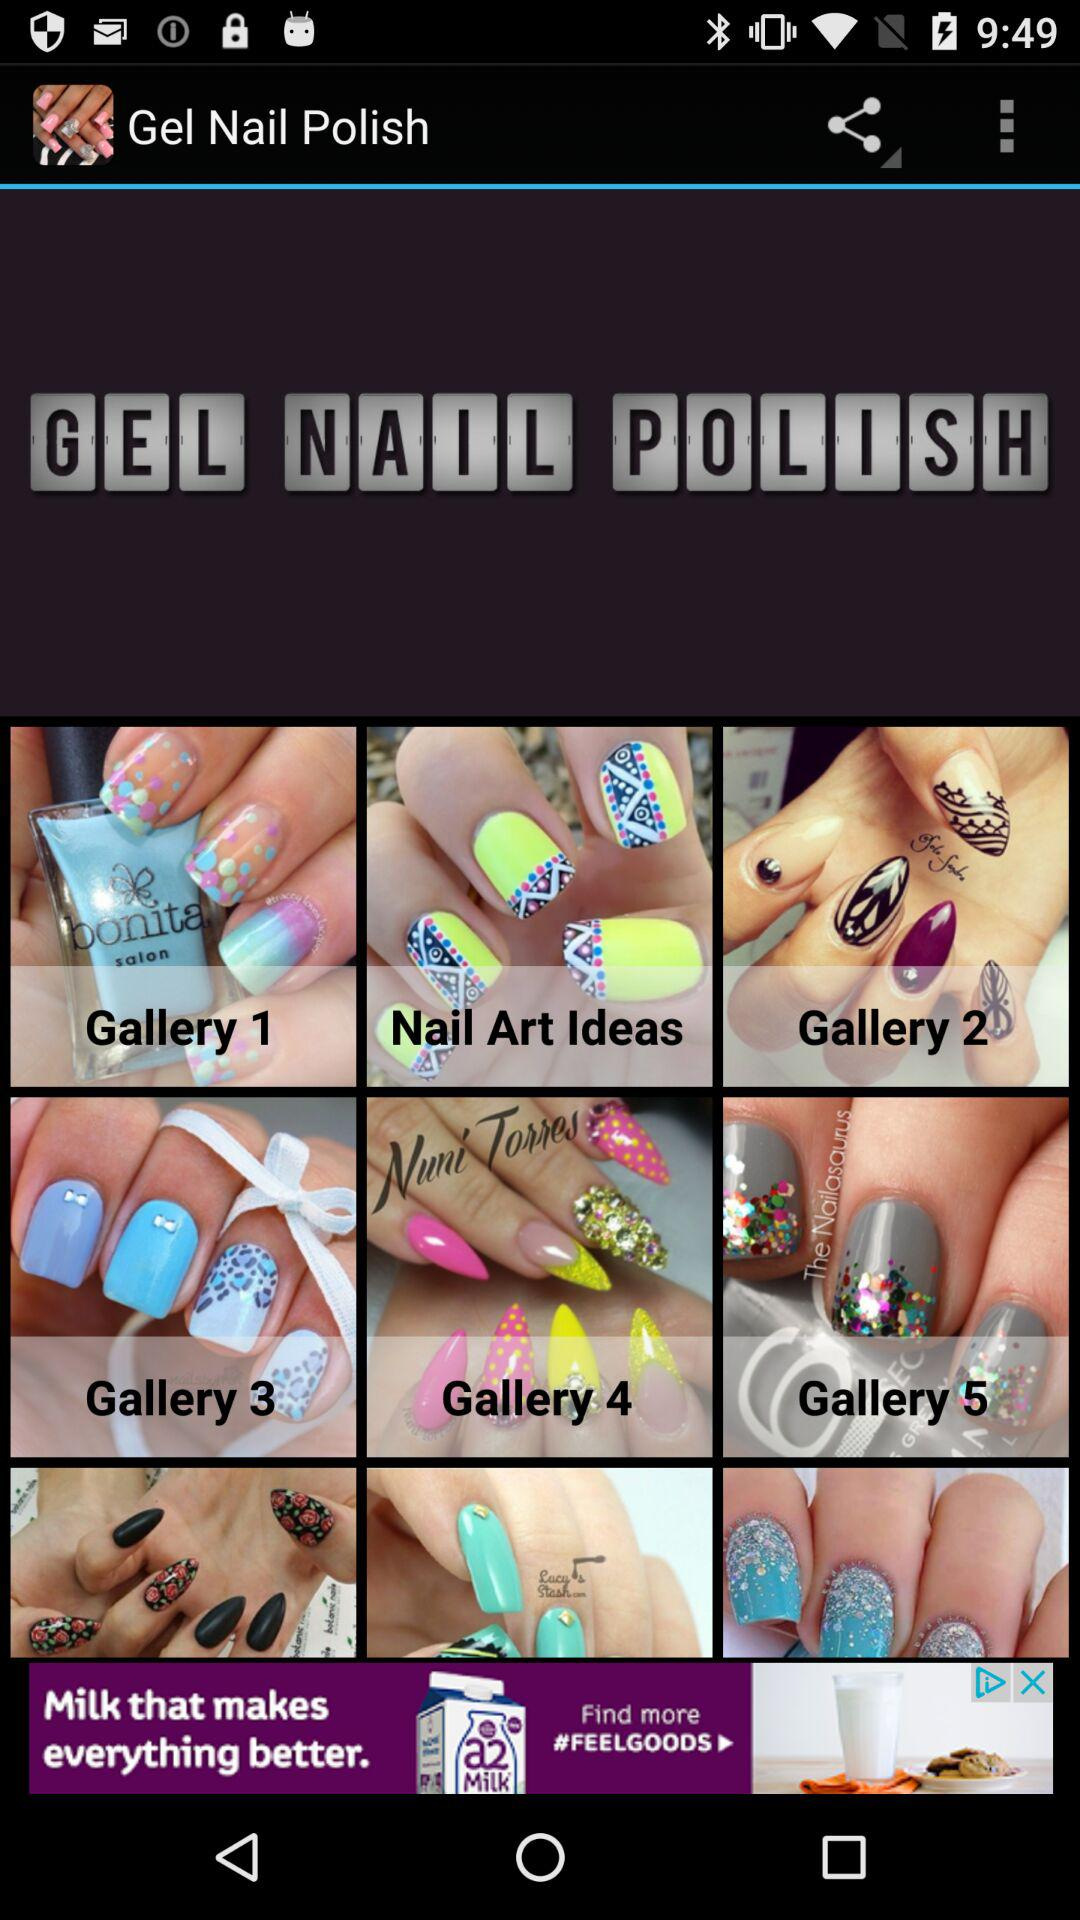What is the name of the application? The name of the application is "Gel Nail Polish". 